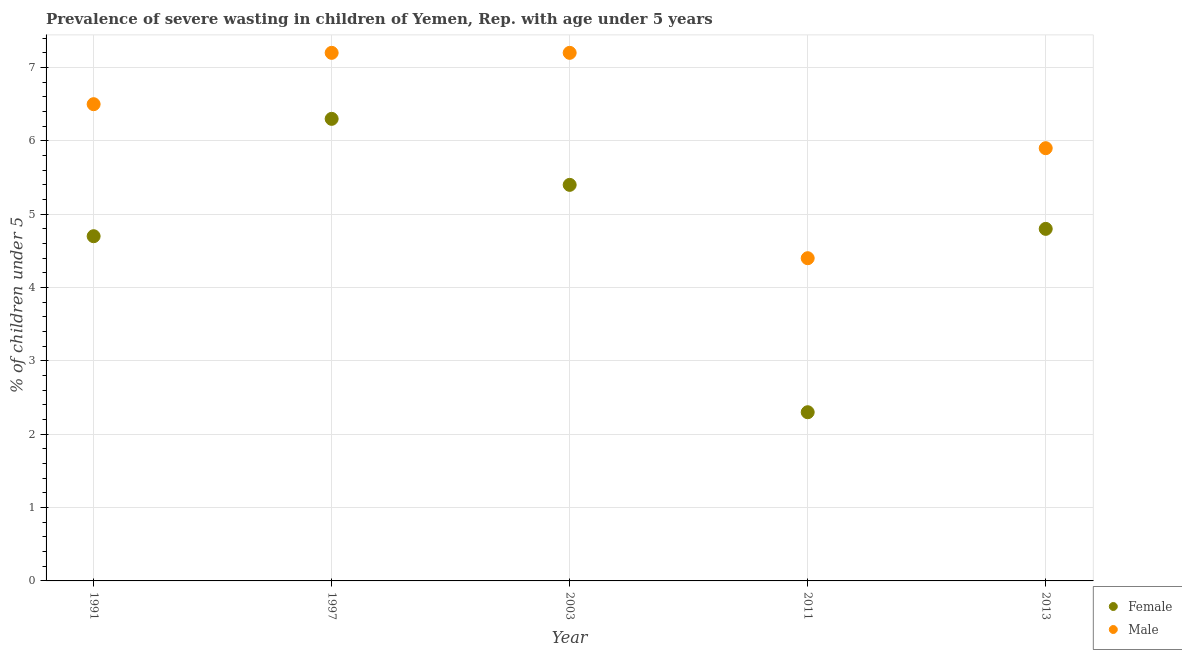How many different coloured dotlines are there?
Ensure brevity in your answer.  2. What is the percentage of undernourished female children in 1997?
Ensure brevity in your answer.  6.3. Across all years, what is the maximum percentage of undernourished male children?
Make the answer very short. 7.2. Across all years, what is the minimum percentage of undernourished male children?
Ensure brevity in your answer.  4.4. In which year was the percentage of undernourished male children maximum?
Your answer should be very brief. 1997. What is the total percentage of undernourished male children in the graph?
Your response must be concise. 31.2. What is the difference between the percentage of undernourished female children in 1991 and that in 2013?
Give a very brief answer. -0.1. What is the difference between the percentage of undernourished female children in 2003 and the percentage of undernourished male children in 1991?
Keep it short and to the point. -1.1. What is the average percentage of undernourished female children per year?
Ensure brevity in your answer.  4.7. In the year 2013, what is the difference between the percentage of undernourished female children and percentage of undernourished male children?
Give a very brief answer. -1.1. In how many years, is the percentage of undernourished female children greater than 3 %?
Provide a succinct answer. 4. What is the ratio of the percentage of undernourished male children in 2003 to that in 2013?
Your answer should be compact. 1.22. Is the difference between the percentage of undernourished male children in 1997 and 2011 greater than the difference between the percentage of undernourished female children in 1997 and 2011?
Offer a terse response. No. What is the difference between the highest and the second highest percentage of undernourished male children?
Provide a succinct answer. 0. What is the difference between the highest and the lowest percentage of undernourished female children?
Give a very brief answer. 4. Does the percentage of undernourished male children monotonically increase over the years?
Your answer should be compact. No. Is the percentage of undernourished female children strictly less than the percentage of undernourished male children over the years?
Offer a terse response. Yes. How many dotlines are there?
Offer a very short reply. 2. What is the difference between two consecutive major ticks on the Y-axis?
Ensure brevity in your answer.  1. Are the values on the major ticks of Y-axis written in scientific E-notation?
Offer a terse response. No. Does the graph contain any zero values?
Make the answer very short. No. Does the graph contain grids?
Ensure brevity in your answer.  Yes. How many legend labels are there?
Your response must be concise. 2. How are the legend labels stacked?
Provide a succinct answer. Vertical. What is the title of the graph?
Your answer should be very brief. Prevalence of severe wasting in children of Yemen, Rep. with age under 5 years. What is the label or title of the Y-axis?
Give a very brief answer.  % of children under 5. What is the  % of children under 5 of Female in 1991?
Provide a short and direct response. 4.7. What is the  % of children under 5 of Male in 1991?
Offer a very short reply. 6.5. What is the  % of children under 5 in Female in 1997?
Your answer should be very brief. 6.3. What is the  % of children under 5 in Male in 1997?
Offer a very short reply. 7.2. What is the  % of children under 5 of Female in 2003?
Offer a terse response. 5.4. What is the  % of children under 5 of Male in 2003?
Make the answer very short. 7.2. What is the  % of children under 5 of Female in 2011?
Offer a terse response. 2.3. What is the  % of children under 5 in Male in 2011?
Your response must be concise. 4.4. What is the  % of children under 5 in Female in 2013?
Offer a very short reply. 4.8. What is the  % of children under 5 in Male in 2013?
Ensure brevity in your answer.  5.9. Across all years, what is the maximum  % of children under 5 of Female?
Make the answer very short. 6.3. Across all years, what is the maximum  % of children under 5 of Male?
Your answer should be compact. 7.2. Across all years, what is the minimum  % of children under 5 in Female?
Your answer should be compact. 2.3. Across all years, what is the minimum  % of children under 5 in Male?
Offer a very short reply. 4.4. What is the total  % of children under 5 in Male in the graph?
Your answer should be very brief. 31.2. What is the difference between the  % of children under 5 in Female in 1991 and that in 1997?
Your response must be concise. -1.6. What is the difference between the  % of children under 5 in Male in 1991 and that in 1997?
Keep it short and to the point. -0.7. What is the difference between the  % of children under 5 of Female in 1991 and that in 2003?
Provide a succinct answer. -0.7. What is the difference between the  % of children under 5 of Male in 1991 and that in 2011?
Provide a succinct answer. 2.1. What is the difference between the  % of children under 5 of Female in 1997 and that in 2003?
Your answer should be very brief. 0.9. What is the difference between the  % of children under 5 of Female in 1997 and that in 2013?
Ensure brevity in your answer.  1.5. What is the difference between the  % of children under 5 of Female in 2003 and that in 2011?
Keep it short and to the point. 3.1. What is the difference between the  % of children under 5 of Male in 2003 and that in 2013?
Your response must be concise. 1.3. What is the difference between the  % of children under 5 in Female in 2011 and that in 2013?
Ensure brevity in your answer.  -2.5. What is the difference between the  % of children under 5 of Female in 1991 and the  % of children under 5 of Male in 1997?
Your answer should be compact. -2.5. What is the difference between the  % of children under 5 of Female in 1991 and the  % of children under 5 of Male in 2003?
Your answer should be compact. -2.5. What is the difference between the  % of children under 5 in Female in 1991 and the  % of children under 5 in Male in 2011?
Offer a terse response. 0.3. What is the difference between the  % of children under 5 of Female in 1991 and the  % of children under 5 of Male in 2013?
Provide a short and direct response. -1.2. What is the difference between the  % of children under 5 of Female in 1997 and the  % of children under 5 of Male in 2011?
Keep it short and to the point. 1.9. What is the difference between the  % of children under 5 of Female in 2003 and the  % of children under 5 of Male in 2013?
Ensure brevity in your answer.  -0.5. What is the difference between the  % of children under 5 of Female in 2011 and the  % of children under 5 of Male in 2013?
Your response must be concise. -3.6. What is the average  % of children under 5 in Female per year?
Make the answer very short. 4.7. What is the average  % of children under 5 in Male per year?
Provide a short and direct response. 6.24. In the year 1991, what is the difference between the  % of children under 5 in Female and  % of children under 5 in Male?
Make the answer very short. -1.8. In the year 2003, what is the difference between the  % of children under 5 in Female and  % of children under 5 in Male?
Ensure brevity in your answer.  -1.8. What is the ratio of the  % of children under 5 in Female in 1991 to that in 1997?
Your answer should be very brief. 0.75. What is the ratio of the  % of children under 5 of Male in 1991 to that in 1997?
Give a very brief answer. 0.9. What is the ratio of the  % of children under 5 of Female in 1991 to that in 2003?
Your response must be concise. 0.87. What is the ratio of the  % of children under 5 of Male in 1991 to that in 2003?
Your answer should be compact. 0.9. What is the ratio of the  % of children under 5 in Female in 1991 to that in 2011?
Provide a short and direct response. 2.04. What is the ratio of the  % of children under 5 in Male in 1991 to that in 2011?
Keep it short and to the point. 1.48. What is the ratio of the  % of children under 5 in Female in 1991 to that in 2013?
Keep it short and to the point. 0.98. What is the ratio of the  % of children under 5 in Male in 1991 to that in 2013?
Ensure brevity in your answer.  1.1. What is the ratio of the  % of children under 5 of Male in 1997 to that in 2003?
Your answer should be very brief. 1. What is the ratio of the  % of children under 5 in Female in 1997 to that in 2011?
Keep it short and to the point. 2.74. What is the ratio of the  % of children under 5 of Male in 1997 to that in 2011?
Provide a short and direct response. 1.64. What is the ratio of the  % of children under 5 in Female in 1997 to that in 2013?
Ensure brevity in your answer.  1.31. What is the ratio of the  % of children under 5 in Male in 1997 to that in 2013?
Your answer should be compact. 1.22. What is the ratio of the  % of children under 5 in Female in 2003 to that in 2011?
Make the answer very short. 2.35. What is the ratio of the  % of children under 5 in Male in 2003 to that in 2011?
Your answer should be compact. 1.64. What is the ratio of the  % of children under 5 of Male in 2003 to that in 2013?
Your response must be concise. 1.22. What is the ratio of the  % of children under 5 in Female in 2011 to that in 2013?
Offer a very short reply. 0.48. What is the ratio of the  % of children under 5 in Male in 2011 to that in 2013?
Your answer should be compact. 0.75. What is the difference between the highest and the lowest  % of children under 5 of Female?
Your answer should be very brief. 4. What is the difference between the highest and the lowest  % of children under 5 in Male?
Your answer should be compact. 2.8. 